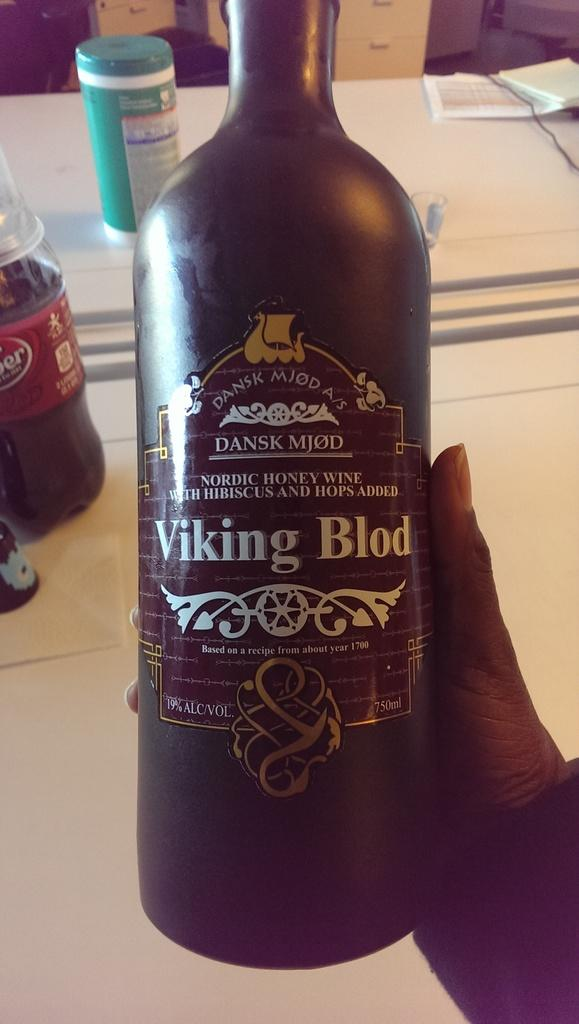<image>
Write a terse but informative summary of the picture. A person is holding up a bottle of Viking Blod. 